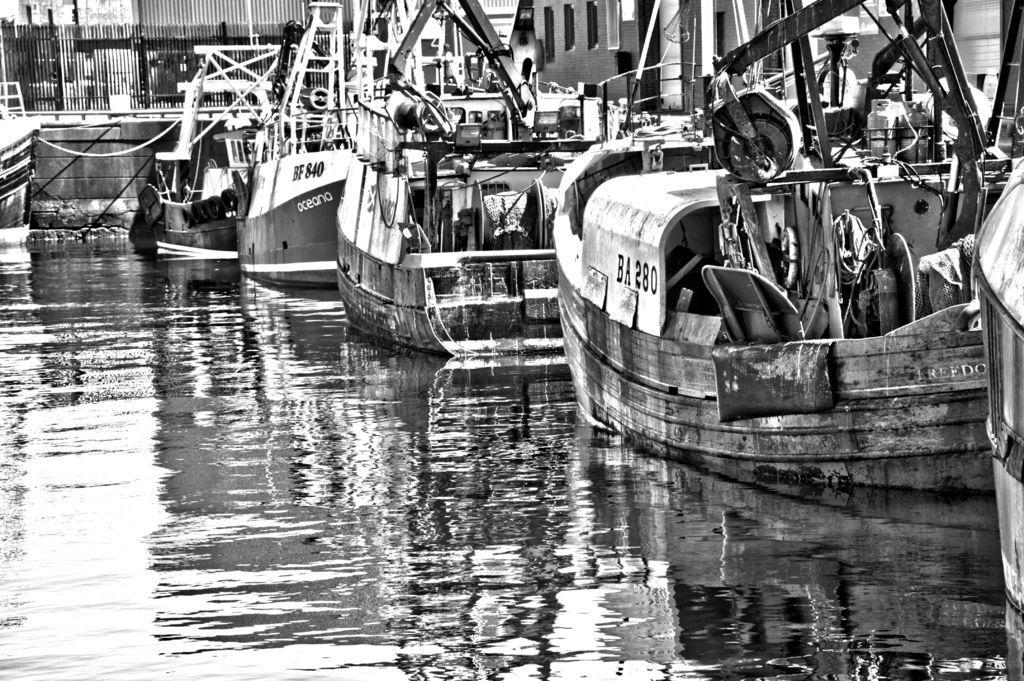In one or two sentences, can you explain what this image depicts? In this image we can see some ships on the water, also we can see the fencing, and the picture is taken in black and white mode. 